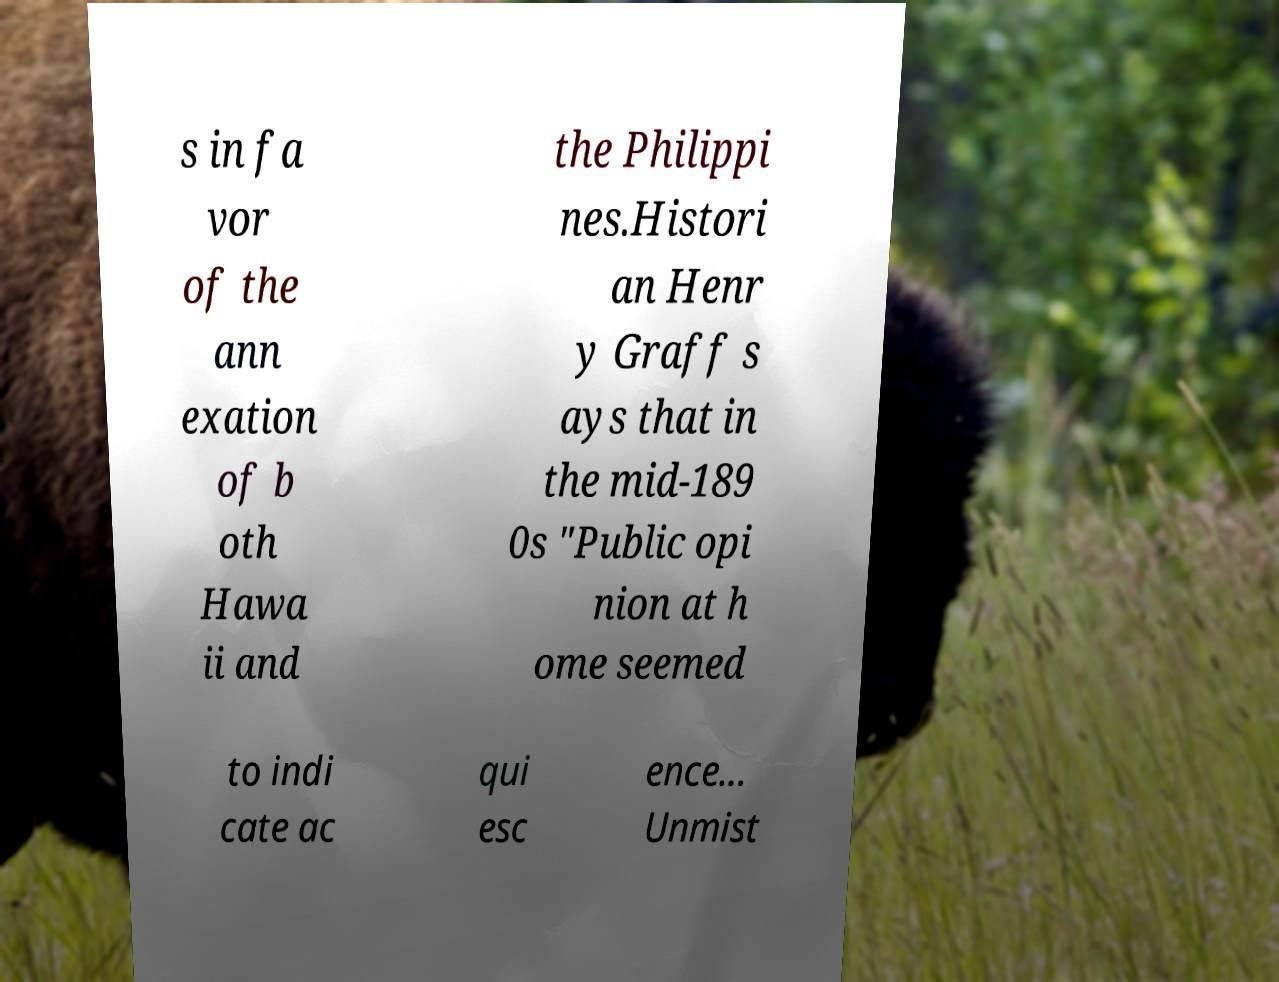Can you read and provide the text displayed in the image?This photo seems to have some interesting text. Can you extract and type it out for me? s in fa vor of the ann exation of b oth Hawa ii and the Philippi nes.Histori an Henr y Graff s ays that in the mid-189 0s "Public opi nion at h ome seemed to indi cate ac qui esc ence... Unmist 